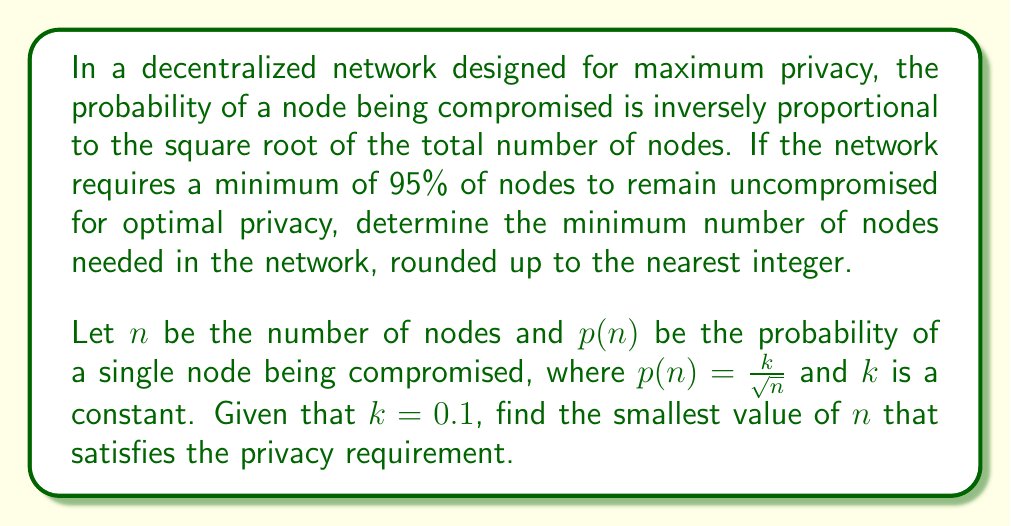Provide a solution to this math problem. Let's approach this step-by-step:

1) The probability of a node being compromised is given by:
   $p(n) = \frac{k}{\sqrt{n}}$, where $k = 0.1$

2) The probability of a node remaining uncompromised is:
   $1 - p(n) = 1 - \frac{0.1}{\sqrt{n}}$

3) For optimal privacy, at least 95% of nodes must remain uncompromised. This can be expressed as:
   $$(1 - \frac{0.1}{\sqrt{n}})^n \geq 0.95$$

4) Taking the natural logarithm of both sides:
   $$n \ln(1 - \frac{0.1}{\sqrt{n}}) \geq \ln(0.95)$$

5) We can use the approximation $\ln(1-x) \approx -x$ for small $x$:
   $$n (-\frac{0.1}{\sqrt{n}}) \geq \ln(0.95)$$

6) Simplifying:
   $$-0.1\sqrt{n} \geq \ln(0.95)$$

7) Solving for $n$:
   $$\sqrt{n} \geq \frac{-\ln(0.95)}{0.1}$$
   $$n \geq (\frac{-\ln(0.95)}{0.1})^2$$

8) Calculating:
   $$n \geq (\frac{0.05129329}{0.1})^2 \approx 26.31$$

9) Since we need to round up to the nearest integer:
   $$n \geq 27$$

Therefore, the minimum number of nodes needed is 27.
Answer: 27 nodes 